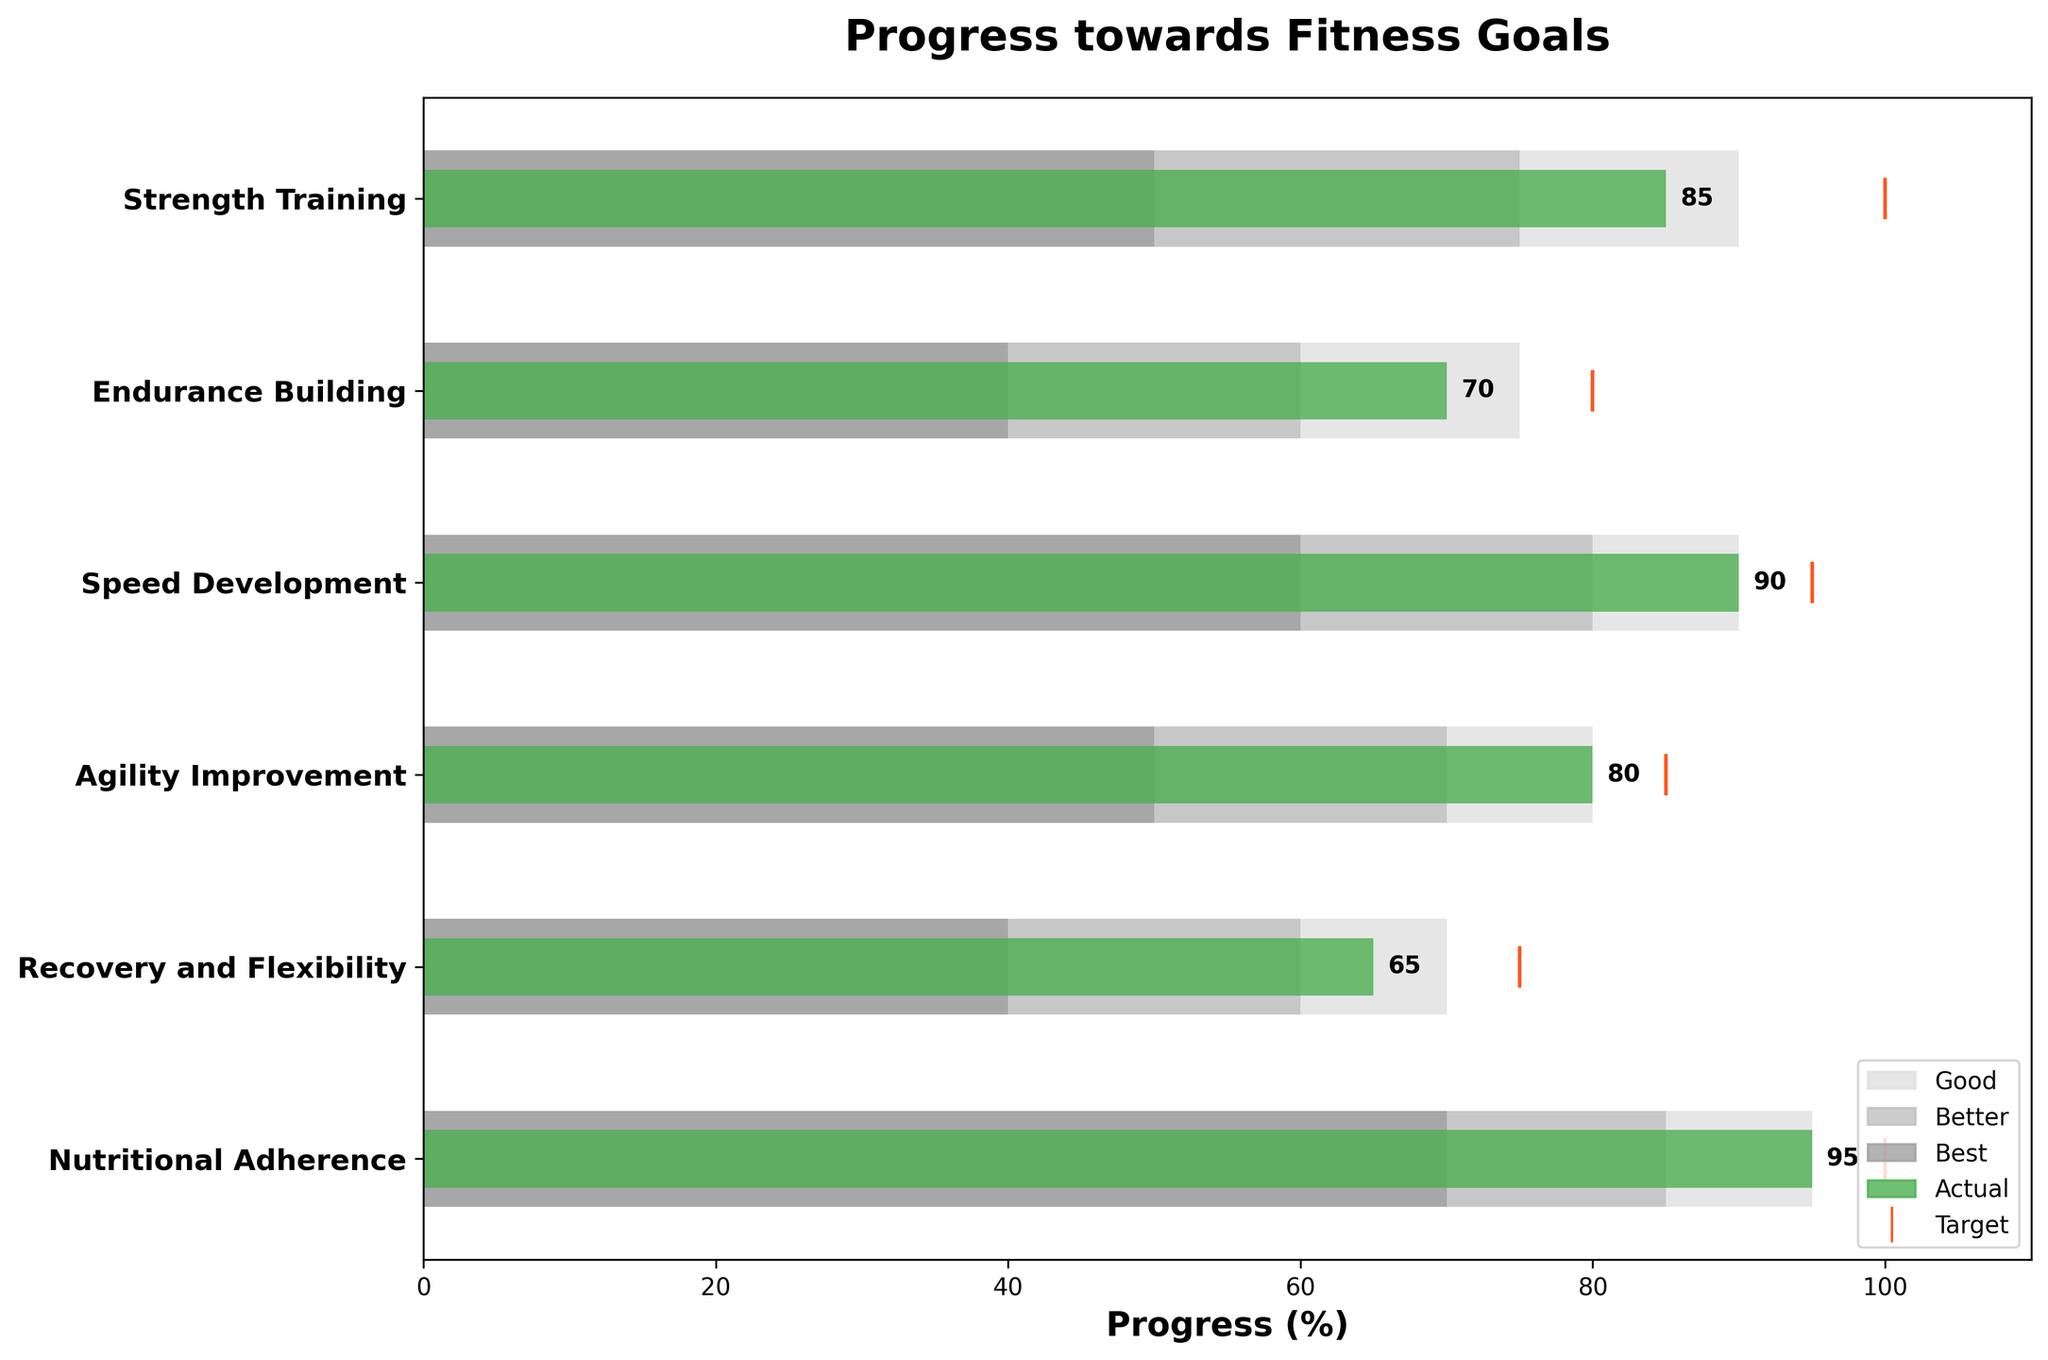How many categories are displayed in the figure? There are six unique training phases listed as categories in the bullet chart: Strength Training, Endurance Building, Speed Development, Agility Improvement, Recovery and Flexibility, and Nutritional Adherence.
Answer: 6 Which category shows the highest actual value? By looking at the actual value bars, Nutritional Adherence has the highest value at 95%.
Answer: Nutritional Adherence Which category is closest to meeting its target? Comparing the actual and target values, Speed Development has an actual value of 90 and a target of 95, which is a difference of 5. This is the smallest difference among all categories.
Answer: Speed Development How many categories have an actual value greater than their "Best" range? Comparing the actual values to the "Best" range, there are two categories: Strength Training (85 > 90) and Nutritional Adherence (95 > 95).
Answer: 2 What is the total sum of all actual values? Sum the actual values for all categories: 85 + 70 + 90 + 80 + 65 + 95 = 485.
Answer: 485 Which category has the smallest difference between its actual value and first range? To find this, look at the absolute differences: Strength Training (85 - 50 = 35), Endurance Building (70 - 40 = 30), Speed Development (90 - 60 = 30), Agility Improvement (80 - 50 = 30), Recovery and Flexibility (65 - 40 = 25), Nutritional Adherence (95 - 70 = 25). Smaller differences are at Recovery and Flexibility, Nutritional Adherence at 25.
Answer: Recovery and Flexibility, Nutritional Adherence Among all categories, which has the most significant improvement needed to reach the "Best" range? To find this, check the difference between the actual value and the top of the "Best" range: Strength Training (90 - 85 = 5), Endurance Building (75 - 70 = 5), Speed Development (90 - 90 = 0), Agility Improvement (80 - 80 = 0), Recovery and Flexibility (70 - 65 = 5), Nutritional Adherence (95 - 95 = 0). The largest improvement needed is for categories where the difference is more than 0, which is Strength Training, Endurance Building, Recovery and Flexibility by 5.
Answer: Strength Training, Endurance Building, Recovery and Flexibility Which category shows the least variance between its "Good," "Better," and "Best" ranges, and what is the variance value? Calculate the variance within each range for each category to find the least: Strength Training (90-50 = 40), Endurance Building (75-40 = 35), Speed Development (90-60 = 30), Agility Improvement (80-50 = 30), Recovery and Flexibility (70-40 = 30), Nutritional Adherence (95-70 = 25). Nutritional Adherence shows the least variance of 25.
Answer: Nutritional Adherence (25) What is the average actual value across all categories? To find the average, divide the total actual values by the number of categories: (85 + 70 + 90 + 80 + 65 + 95) / 6 = 485 / 6 ≈ 80.83.
Answer: 80.83 